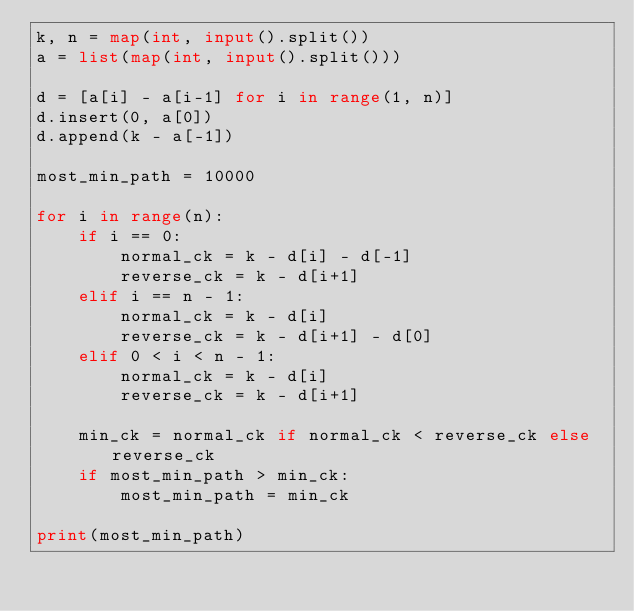<code> <loc_0><loc_0><loc_500><loc_500><_Python_>k, n = map(int, input().split())
a = list(map(int, input().split()))
 
d = [a[i] - a[i-1] for i in range(1, n)]
d.insert(0, a[0])
d.append(k - a[-1])
 
most_min_path = 10000
 
for i in range(n):
    if i == 0:
        normal_ck = k - d[i] - d[-1]
        reverse_ck = k - d[i+1]
    elif i == n - 1:
        normal_ck = k - d[i]
        reverse_ck = k - d[i+1] - d[0]
    elif 0 < i < n - 1:
        normal_ck = k - d[i]
        reverse_ck = k - d[i+1]
 
    min_ck = normal_ck if normal_ck < reverse_ck else reverse_ck
    if most_min_path > min_ck:
        most_min_path = min_ck

print(most_min_path)</code> 